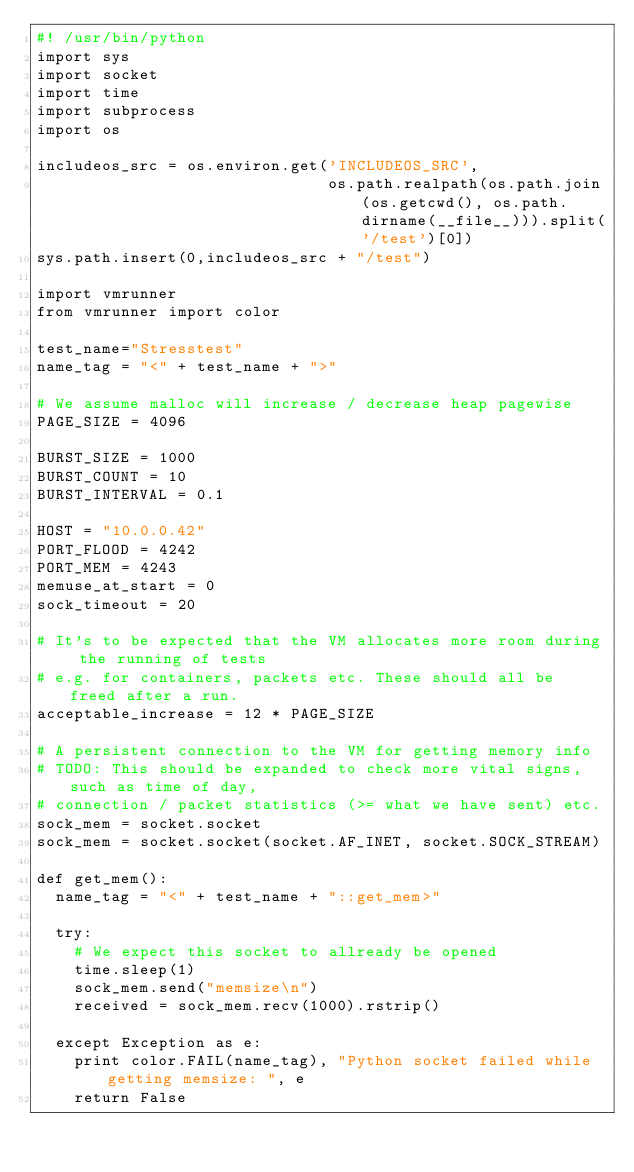<code> <loc_0><loc_0><loc_500><loc_500><_Python_>#! /usr/bin/python
import sys
import socket
import time
import subprocess
import os

includeos_src = os.environ.get('INCLUDEOS_SRC',
                               os.path.realpath(os.path.join(os.getcwd(), os.path.dirname(__file__))).split('/test')[0])
sys.path.insert(0,includeos_src + "/test")

import vmrunner
from vmrunner import color

test_name="Stresstest"
name_tag = "<" + test_name + ">"

# We assume malloc will increase / decrease heap pagewise
PAGE_SIZE = 4096

BURST_SIZE = 1000
BURST_COUNT = 10
BURST_INTERVAL = 0.1

HOST = "10.0.0.42"
PORT_FLOOD = 4242
PORT_MEM = 4243
memuse_at_start = 0
sock_timeout = 20

# It's to be expected that the VM allocates more room during the running of tests
# e.g. for containers, packets etc. These should all be freed after a run.
acceptable_increase = 12 * PAGE_SIZE

# A persistent connection to the VM for getting memory info
# TODO: This should be expanded to check more vital signs, such as time of day,
# connection / packet statistics (>= what we have sent) etc.
sock_mem = socket.socket
sock_mem = socket.socket(socket.AF_INET, socket.SOCK_STREAM)

def get_mem():
  name_tag = "<" + test_name + "::get_mem>"

  try:
    # We expect this socket to allready be opened
    time.sleep(1)
    sock_mem.send("memsize\n")
    received = sock_mem.recv(1000).rstrip()

  except Exception as e:
    print color.FAIL(name_tag), "Python socket failed while getting memsize: ", e
    return False
</code> 